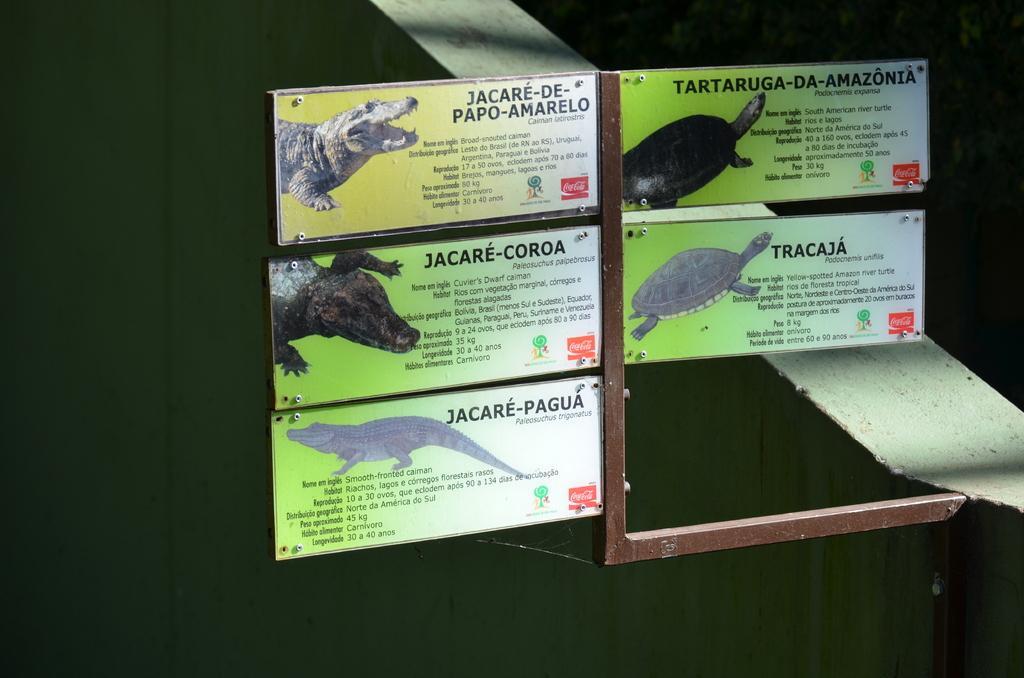How would you summarize this image in a sentence or two? In this picture I can see few boards with images and some text and I can see dark background. 